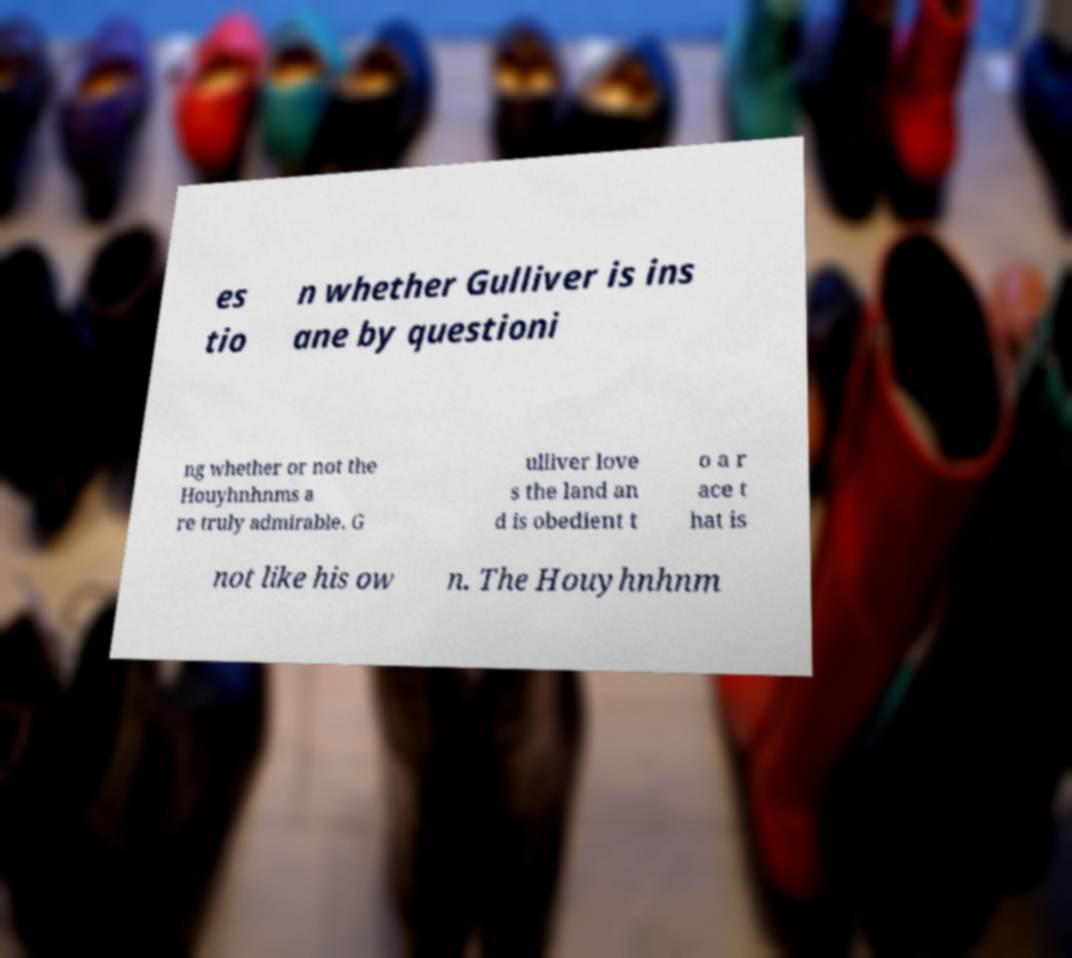Please read and relay the text visible in this image. What does it say? es tio n whether Gulliver is ins ane by questioni ng whether or not the Houyhnhnms a re truly admirable. G ulliver love s the land an d is obedient t o a r ace t hat is not like his ow n. The Houyhnhnm 